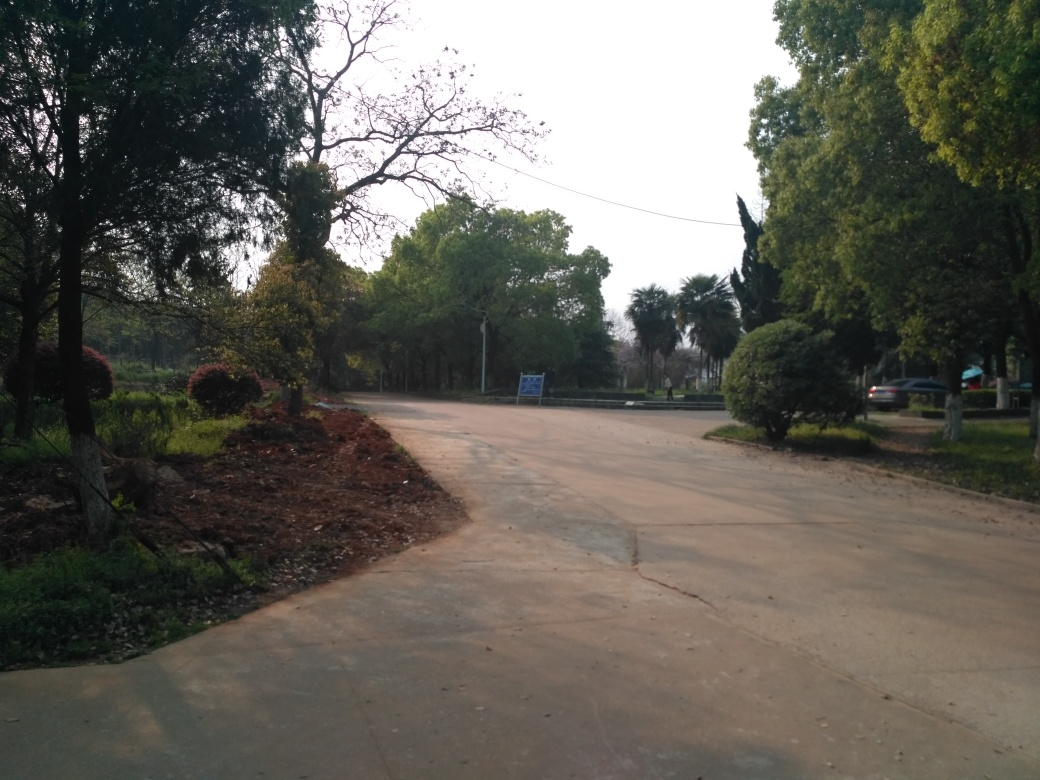What is the amount of noise in this image? The image appears to be taken in a relatively quiet outdoor setting with no immediate signs of heavy traffic or industrial activity. The photo suggests a calm environment with potential ambient sounds from nature, such as the rustling of leaves or distant bird calls. There is no visual cue indicating significant noise pollution. 